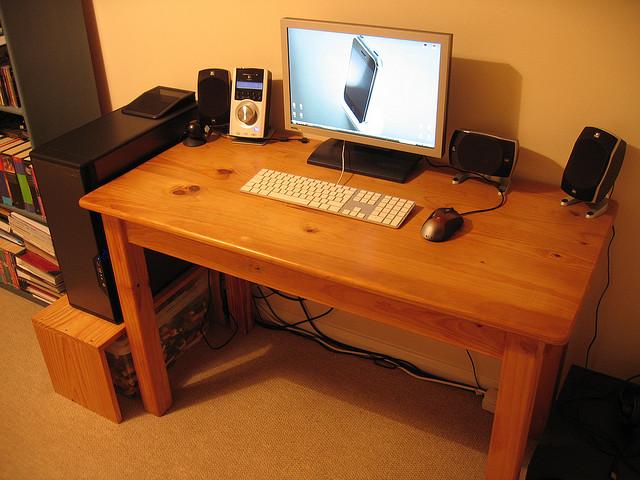Is the desktop wallpaper recursive, showing just a picture of another computer?
Quick response, please. Yes. What is next to the keyboard?
Give a very brief answer. Mouse. Are the wire hidden?
Answer briefly. No. Are the cords organized neatly?
Answer briefly. No. What color are the speakers?
Be succinct. Black. 